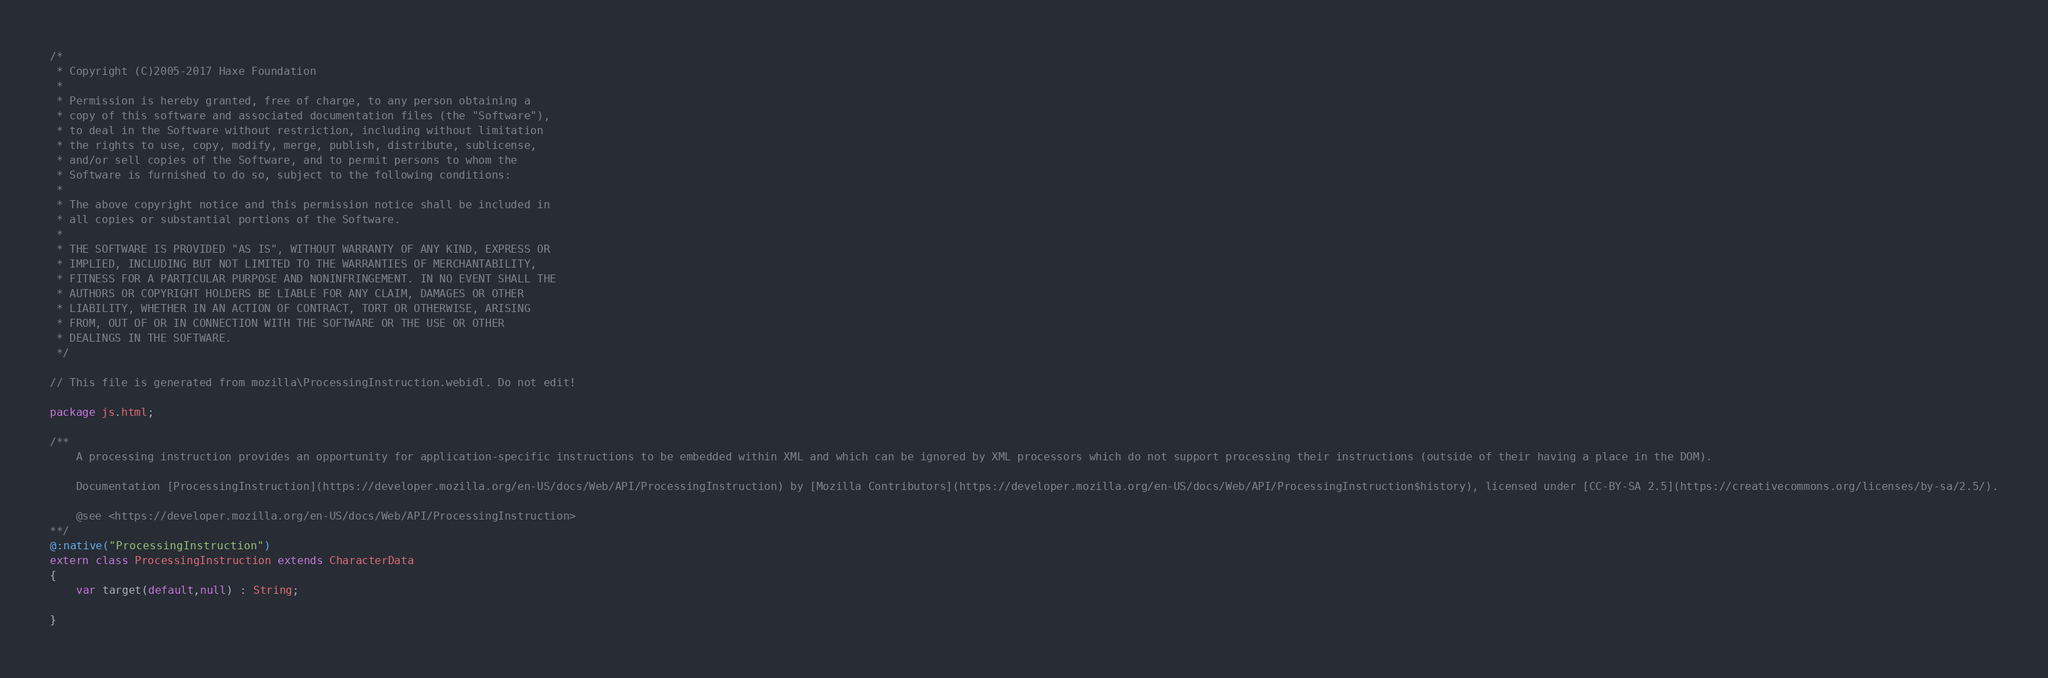Convert code to text. <code><loc_0><loc_0><loc_500><loc_500><_Haxe_>/*
 * Copyright (C)2005-2017 Haxe Foundation
 *
 * Permission is hereby granted, free of charge, to any person obtaining a
 * copy of this software and associated documentation files (the "Software"),
 * to deal in the Software without restriction, including without limitation
 * the rights to use, copy, modify, merge, publish, distribute, sublicense,
 * and/or sell copies of the Software, and to permit persons to whom the
 * Software is furnished to do so, subject to the following conditions:
 *
 * The above copyright notice and this permission notice shall be included in
 * all copies or substantial portions of the Software.
 *
 * THE SOFTWARE IS PROVIDED "AS IS", WITHOUT WARRANTY OF ANY KIND, EXPRESS OR
 * IMPLIED, INCLUDING BUT NOT LIMITED TO THE WARRANTIES OF MERCHANTABILITY,
 * FITNESS FOR A PARTICULAR PURPOSE AND NONINFRINGEMENT. IN NO EVENT SHALL THE
 * AUTHORS OR COPYRIGHT HOLDERS BE LIABLE FOR ANY CLAIM, DAMAGES OR OTHER
 * LIABILITY, WHETHER IN AN ACTION OF CONTRACT, TORT OR OTHERWISE, ARISING
 * FROM, OUT OF OR IN CONNECTION WITH THE SOFTWARE OR THE USE OR OTHER
 * DEALINGS IN THE SOFTWARE.
 */

// This file is generated from mozilla\ProcessingInstruction.webidl. Do not edit!

package js.html;

/**
	A processing instruction provides an opportunity for application-specific instructions to be embedded within XML and which can be ignored by XML processors which do not support processing their instructions (outside of their having a place in the DOM).

	Documentation [ProcessingInstruction](https://developer.mozilla.org/en-US/docs/Web/API/ProcessingInstruction) by [Mozilla Contributors](https://developer.mozilla.org/en-US/docs/Web/API/ProcessingInstruction$history), licensed under [CC-BY-SA 2.5](https://creativecommons.org/licenses/by-sa/2.5/).

	@see <https://developer.mozilla.org/en-US/docs/Web/API/ProcessingInstruction>
**/
@:native("ProcessingInstruction")
extern class ProcessingInstruction extends CharacterData
{
	var target(default,null) : String;
	
}</code> 